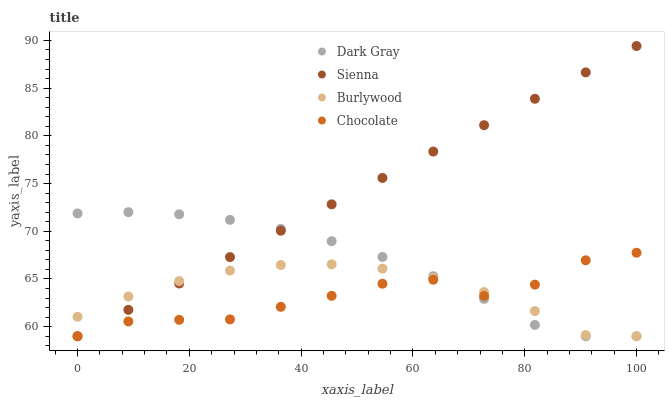Does Chocolate have the minimum area under the curve?
Answer yes or no. Yes. Does Sienna have the maximum area under the curve?
Answer yes or no. Yes. Does Burlywood have the minimum area under the curve?
Answer yes or no. No. Does Burlywood have the maximum area under the curve?
Answer yes or no. No. Is Sienna the smoothest?
Answer yes or no. Yes. Is Chocolate the roughest?
Answer yes or no. Yes. Is Burlywood the smoothest?
Answer yes or no. No. Is Burlywood the roughest?
Answer yes or no. No. Does Dark Gray have the lowest value?
Answer yes or no. Yes. Does Sienna have the highest value?
Answer yes or no. Yes. Does Burlywood have the highest value?
Answer yes or no. No. Does Chocolate intersect Burlywood?
Answer yes or no. Yes. Is Chocolate less than Burlywood?
Answer yes or no. No. Is Chocolate greater than Burlywood?
Answer yes or no. No. 